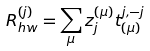Convert formula to latex. <formula><loc_0><loc_0><loc_500><loc_500>R _ { h w } ^ { ( j ) } = \sum _ { \mu } z _ { j } ^ { ( \mu ) } t _ { ( \mu ) } ^ { j , - j }</formula> 